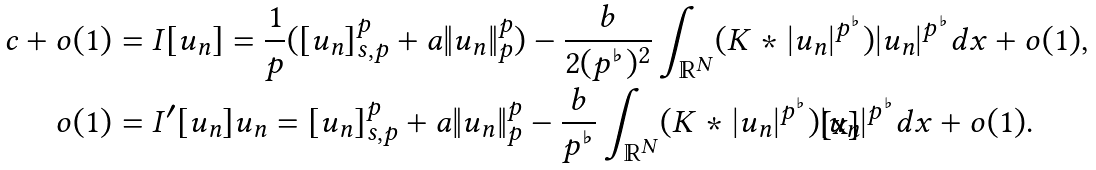Convert formula to latex. <formula><loc_0><loc_0><loc_500><loc_500>c + o ( 1 ) & = I [ u _ { n } ] = \frac { 1 } { p } ( [ u _ { n } ] _ { s , p } ^ { p } + a \| u _ { n } \| _ { p } ^ { p } ) - \frac { b } { 2 ( p ^ { \flat } ) ^ { 2 } } \int _ { \mathbb { R } ^ { N } } ( K \ast | u _ { n } | ^ { p ^ { \flat } } ) | u _ { n } | ^ { p ^ { \flat } } d x + o ( 1 ) , \\ o ( 1 ) & = I ^ { \prime } [ u _ { n } ] u _ { n } = [ u _ { n } ] _ { s , p } ^ { p } + a \| u _ { n } \| _ { p } ^ { p } - \frac { b } { p ^ { \flat } } \int _ { \mathbb { R } ^ { N } } ( K \ast | u _ { n } | ^ { p ^ { \flat } } ) | u _ { n } | ^ { p ^ { \flat } } d x + o ( 1 ) .</formula> 